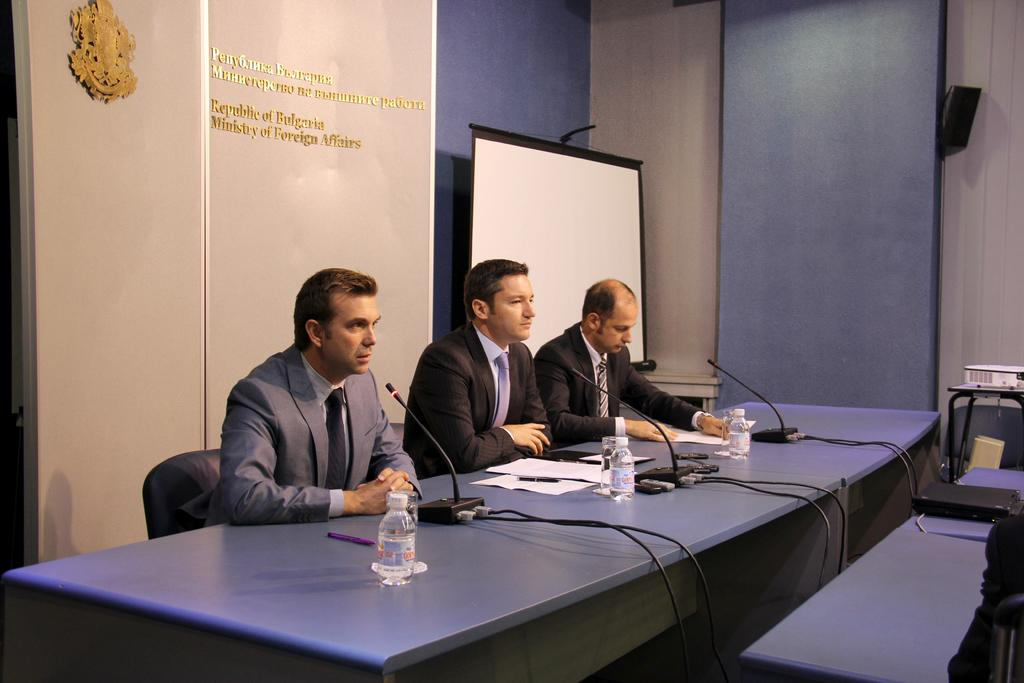How many men are in the image? There are three men in the image. What are the men doing in the image? The men are sitting on chairs. What is in front of the men? The men are in front of a table. What can be seen on the table? There are mice and bottles on the table. What is visible in the background of the image? There is a wall and a speaker in the background of the image. How many bikes are parked next to the men in the image? There are no bikes present in the image. What type of family gathering is depicted in the image? The image does not depict a family gathering; it features three men sitting in front of a table. 